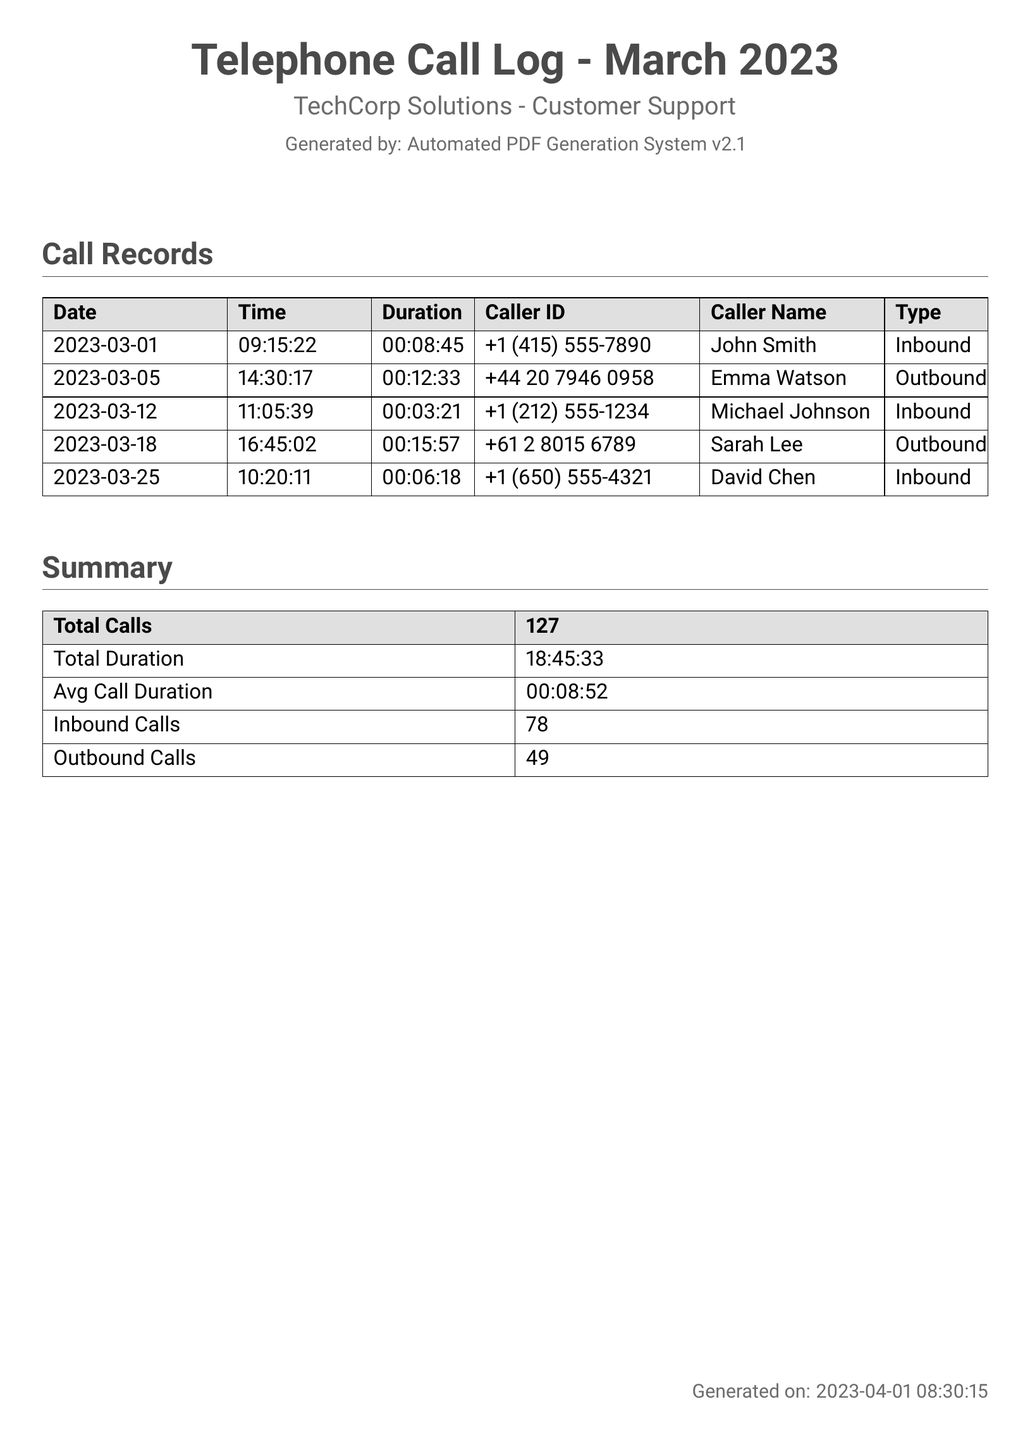What is the total number of calls? The total number of calls is provided in the summary section of the document, which states "Total Calls" as 127.
Answer: 127 What is the duration of the longest call? To determine the longest call duration, we can look at the individual call durations listed; the longest call is 00:15:57 by Sarah Lee.
Answer: 00:15:57 Who made the outbound call on March 18? The outbound call on March 18 is made by Sarah Lee, as per the details listed in the call records.
Answer: Sarah Lee What is the total duration of calls for March 2023? The total duration of all calls that month is expressed in the summary section, listed as 18:45:33.
Answer: 18:45:33 How many inbound calls were recorded? The number of inbound calls is shown in the summary, with "Inbound Calls" stating 78.
Answer: 78 What is the average call duration? The average call duration is calculated and provided in the summary section as 00:08:52.
Answer: 00:08:52 How many outbound calls were there? The document lists the total number of outbound calls in the summary section, which is 49.
Answer: 49 What date and time was the first recorded call? The first recorded call appears in the call records; it was made on March 1 at 09:15:22.
Answer: 2023-03-01 09:15:22 Which caller ID corresponds to Emma Watson? The caller ID " +44 20 7946 0958" is listed next to Emma Watson in the call records.
Answer: +44 20 7946 0958 